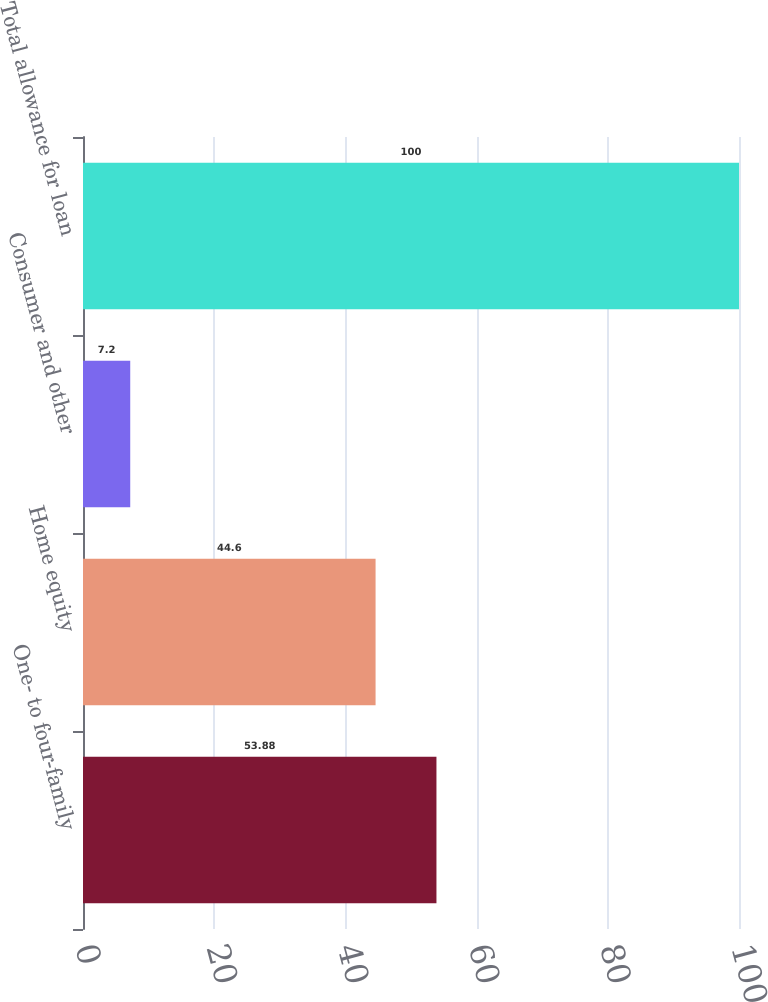<chart> <loc_0><loc_0><loc_500><loc_500><bar_chart><fcel>One- to four-family<fcel>Home equity<fcel>Consumer and other<fcel>Total allowance for loan<nl><fcel>53.88<fcel>44.6<fcel>7.2<fcel>100<nl></chart> 